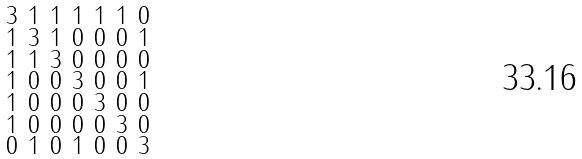<formula> <loc_0><loc_0><loc_500><loc_500>\begin{smallmatrix} 3 & 1 & 1 & 1 & 1 & 1 & 0 \\ 1 & 3 & 1 & 0 & 0 & 0 & 1 \\ 1 & 1 & 3 & 0 & 0 & 0 & 0 \\ 1 & 0 & 0 & 3 & 0 & 0 & 1 \\ 1 & 0 & 0 & 0 & 3 & 0 & 0 \\ 1 & 0 & 0 & 0 & 0 & 3 & 0 \\ 0 & 1 & 0 & 1 & 0 & 0 & 3 \end{smallmatrix}</formula> 